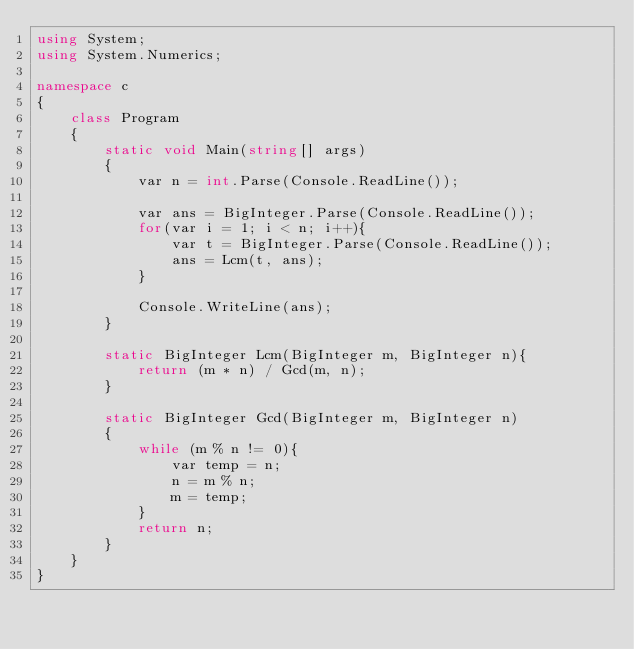<code> <loc_0><loc_0><loc_500><loc_500><_C#_>using System;
using System.Numerics;

namespace c
{
    class Program
    {
        static void Main(string[] args)
        {
            var n = int.Parse(Console.ReadLine());

            var ans = BigInteger.Parse(Console.ReadLine());
            for(var i = 1; i < n; i++){
                var t = BigInteger.Parse(Console.ReadLine());
                ans = Lcm(t, ans);
            }

            Console.WriteLine(ans);
        }

        static BigInteger Lcm(BigInteger m, BigInteger n){
        	return (m * n) / Gcd(m, n);
        }

        static BigInteger Gcd(BigInteger m, BigInteger n)
        {
	        while (m % n != 0){
        		var temp = n;
		        n = m % n;
		        m = temp;
	        }
        	return n;
        }
    }
}
</code> 